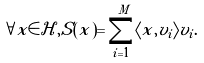Convert formula to latex. <formula><loc_0><loc_0><loc_500><loc_500>\forall x \in \mathcal { H } , S ( x ) = \sum _ { i = 1 } ^ { M } \langle x , v _ { i } \rangle v _ { i } .</formula> 